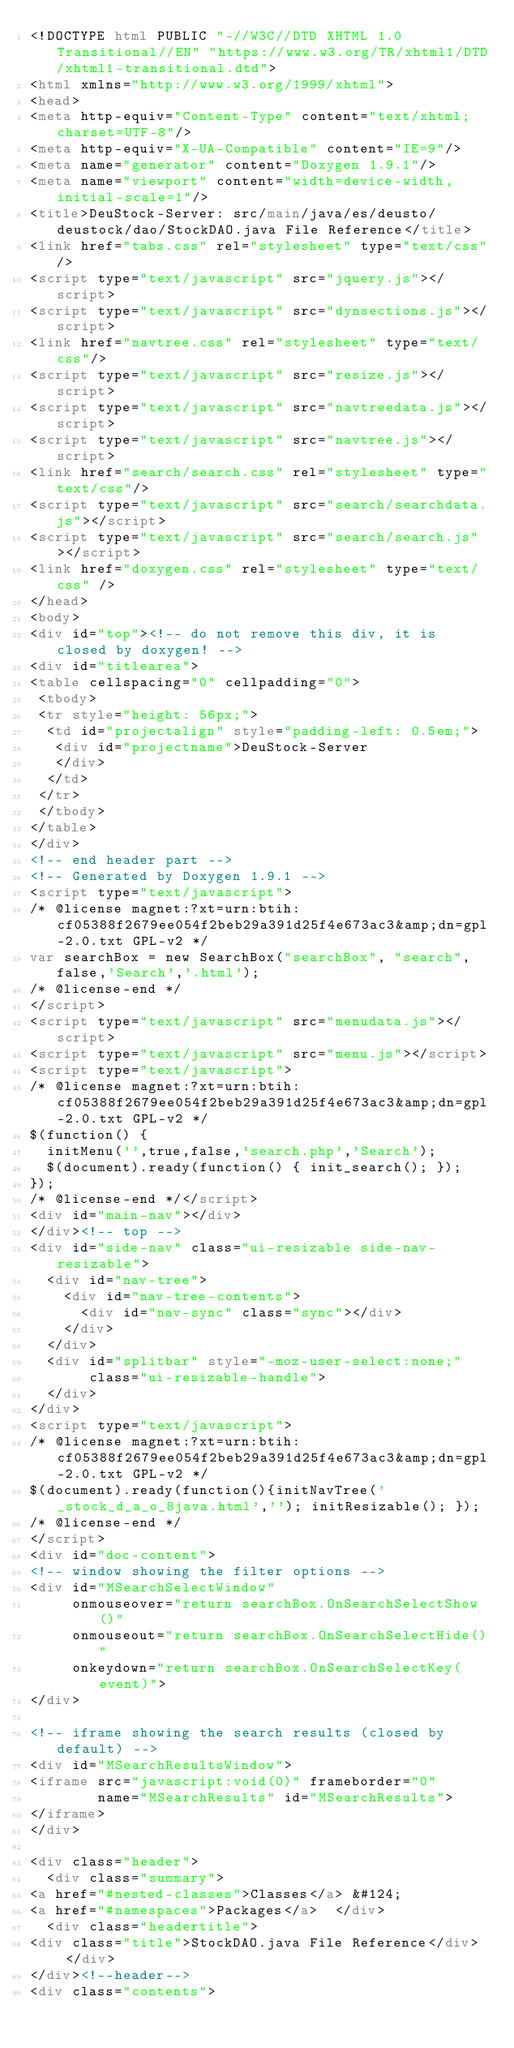<code> <loc_0><loc_0><loc_500><loc_500><_HTML_><!DOCTYPE html PUBLIC "-//W3C//DTD XHTML 1.0 Transitional//EN" "https://www.w3.org/TR/xhtml1/DTD/xhtml1-transitional.dtd">
<html xmlns="http://www.w3.org/1999/xhtml">
<head>
<meta http-equiv="Content-Type" content="text/xhtml;charset=UTF-8"/>
<meta http-equiv="X-UA-Compatible" content="IE=9"/>
<meta name="generator" content="Doxygen 1.9.1"/>
<meta name="viewport" content="width=device-width, initial-scale=1"/>
<title>DeuStock-Server: src/main/java/es/deusto/deustock/dao/StockDAO.java File Reference</title>
<link href="tabs.css" rel="stylesheet" type="text/css"/>
<script type="text/javascript" src="jquery.js"></script>
<script type="text/javascript" src="dynsections.js"></script>
<link href="navtree.css" rel="stylesheet" type="text/css"/>
<script type="text/javascript" src="resize.js"></script>
<script type="text/javascript" src="navtreedata.js"></script>
<script type="text/javascript" src="navtree.js"></script>
<link href="search/search.css" rel="stylesheet" type="text/css"/>
<script type="text/javascript" src="search/searchdata.js"></script>
<script type="text/javascript" src="search/search.js"></script>
<link href="doxygen.css" rel="stylesheet" type="text/css" />
</head>
<body>
<div id="top"><!-- do not remove this div, it is closed by doxygen! -->
<div id="titlearea">
<table cellspacing="0" cellpadding="0">
 <tbody>
 <tr style="height: 56px;">
  <td id="projectalign" style="padding-left: 0.5em;">
   <div id="projectname">DeuStock-Server
   </div>
  </td>
 </tr>
 </tbody>
</table>
</div>
<!-- end header part -->
<!-- Generated by Doxygen 1.9.1 -->
<script type="text/javascript">
/* @license magnet:?xt=urn:btih:cf05388f2679ee054f2beb29a391d25f4e673ac3&amp;dn=gpl-2.0.txt GPL-v2 */
var searchBox = new SearchBox("searchBox", "search",false,'Search','.html');
/* @license-end */
</script>
<script type="text/javascript" src="menudata.js"></script>
<script type="text/javascript" src="menu.js"></script>
<script type="text/javascript">
/* @license magnet:?xt=urn:btih:cf05388f2679ee054f2beb29a391d25f4e673ac3&amp;dn=gpl-2.0.txt GPL-v2 */
$(function() {
  initMenu('',true,false,'search.php','Search');
  $(document).ready(function() { init_search(); });
});
/* @license-end */</script>
<div id="main-nav"></div>
</div><!-- top -->
<div id="side-nav" class="ui-resizable side-nav-resizable">
  <div id="nav-tree">
    <div id="nav-tree-contents">
      <div id="nav-sync" class="sync"></div>
    </div>
  </div>
  <div id="splitbar" style="-moz-user-select:none;" 
       class="ui-resizable-handle">
  </div>
</div>
<script type="text/javascript">
/* @license magnet:?xt=urn:btih:cf05388f2679ee054f2beb29a391d25f4e673ac3&amp;dn=gpl-2.0.txt GPL-v2 */
$(document).ready(function(){initNavTree('_stock_d_a_o_8java.html',''); initResizable(); });
/* @license-end */
</script>
<div id="doc-content">
<!-- window showing the filter options -->
<div id="MSearchSelectWindow"
     onmouseover="return searchBox.OnSearchSelectShow()"
     onmouseout="return searchBox.OnSearchSelectHide()"
     onkeydown="return searchBox.OnSearchSelectKey(event)">
</div>

<!-- iframe showing the search results (closed by default) -->
<div id="MSearchResultsWindow">
<iframe src="javascript:void(0)" frameborder="0" 
        name="MSearchResults" id="MSearchResults">
</iframe>
</div>

<div class="header">
  <div class="summary">
<a href="#nested-classes">Classes</a> &#124;
<a href="#namespaces">Packages</a>  </div>
  <div class="headertitle">
<div class="title">StockDAO.java File Reference</div>  </div>
</div><!--header-->
<div class="contents">
</code> 